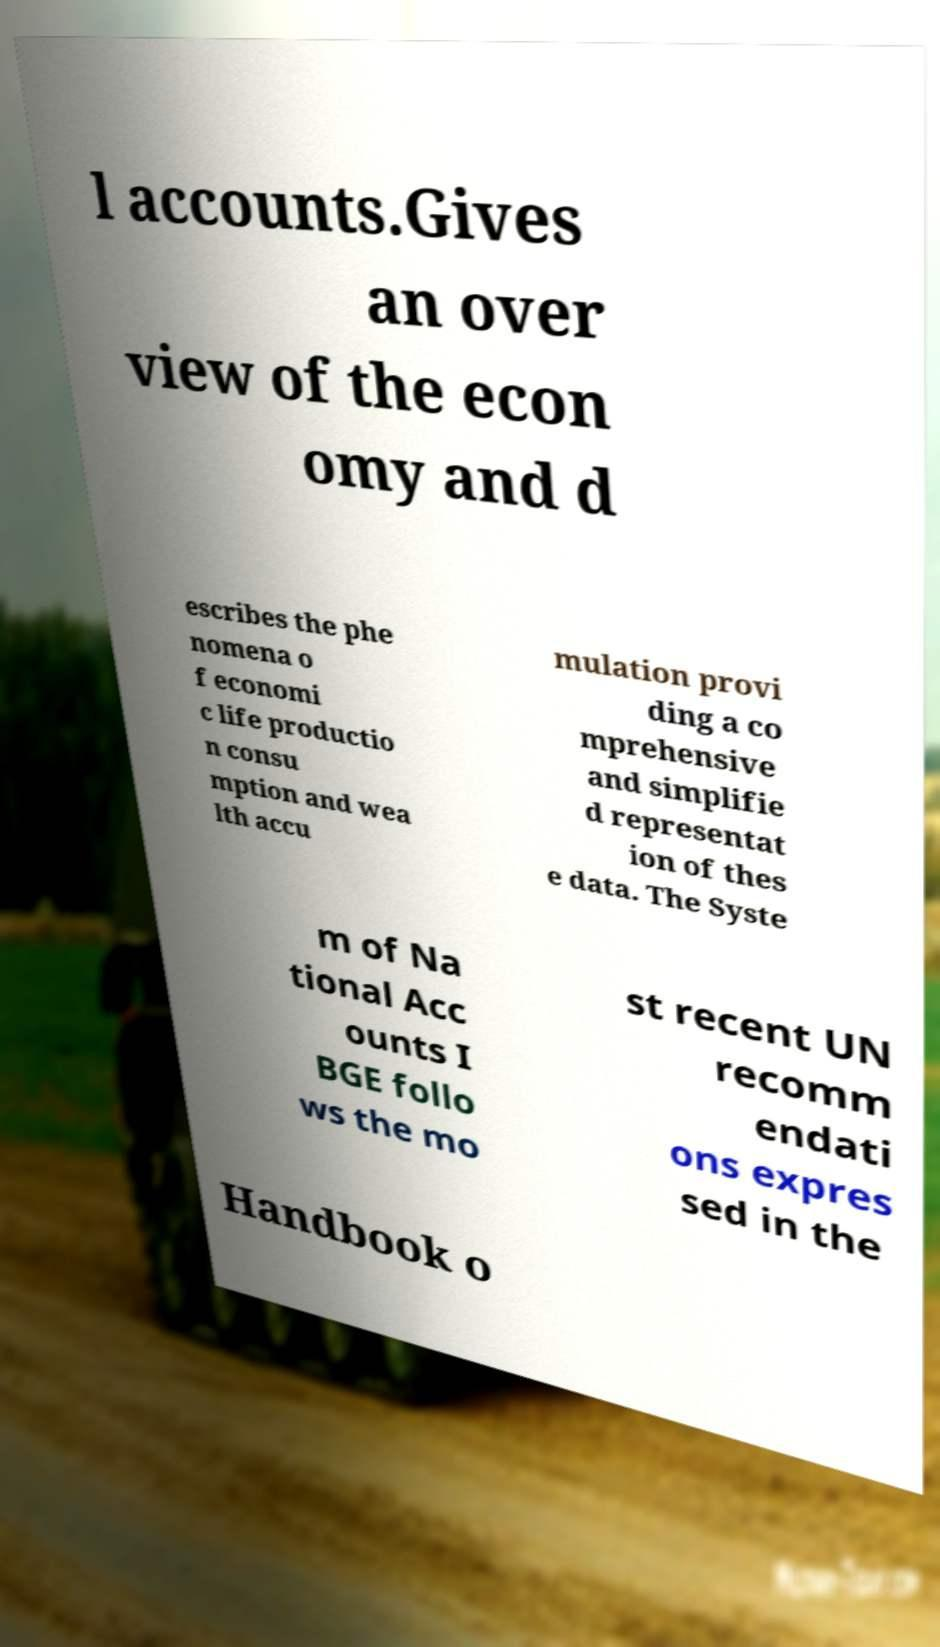I need the written content from this picture converted into text. Can you do that? l accounts.Gives an over view of the econ omy and d escribes the phe nomena o f economi c life productio n consu mption and wea lth accu mulation provi ding a co mprehensive and simplifie d representat ion of thes e data. The Syste m of Na tional Acc ounts I BGE follo ws the mo st recent UN recomm endati ons expres sed in the Handbook o 